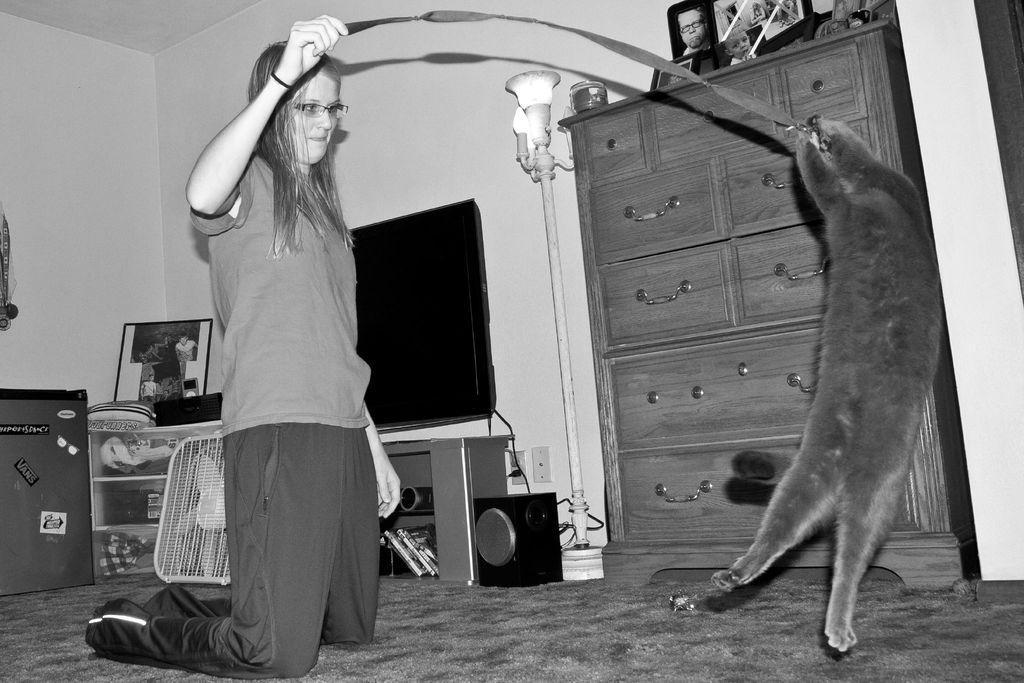Please provide a concise description of this image. It is a black and white image. In this image, we can see a woman and animal are holding an object. At the bottom, we can see the surface. Background we can see television, photo frames, cupboard, racks, speaker, wall, rod, lights, wires and sockets. 